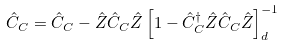Convert formula to latex. <formula><loc_0><loc_0><loc_500><loc_500>\hat { C } _ { C } = \hat { C } _ { C } - \hat { Z } \hat { C } _ { C } \hat { Z } \left [ 1 - \hat { C } _ { C } ^ { \dag } \hat { Z } \hat { C } _ { C } \hat { Z } \right ] _ { d } ^ { - 1 }</formula> 